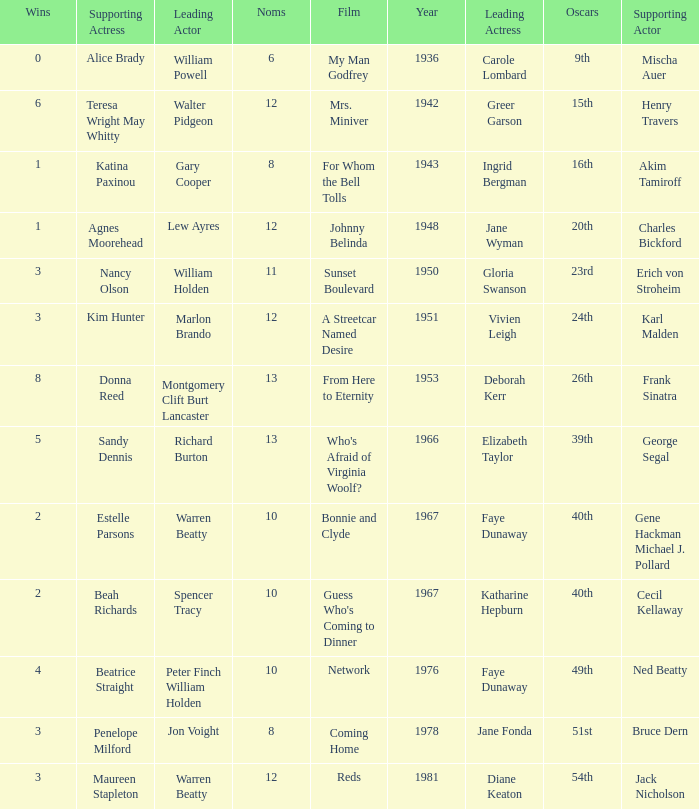Who was the supporting actress in 1943? Katina Paxinou. 